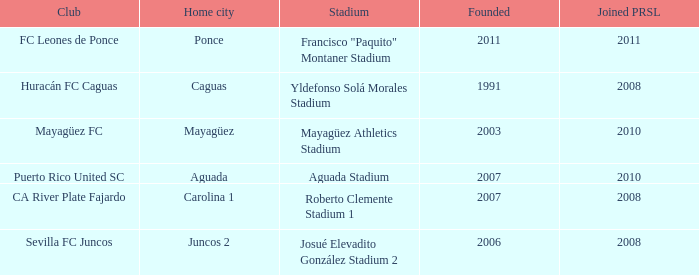What is the earliest established when the home city is mayagüez? 2003.0. 